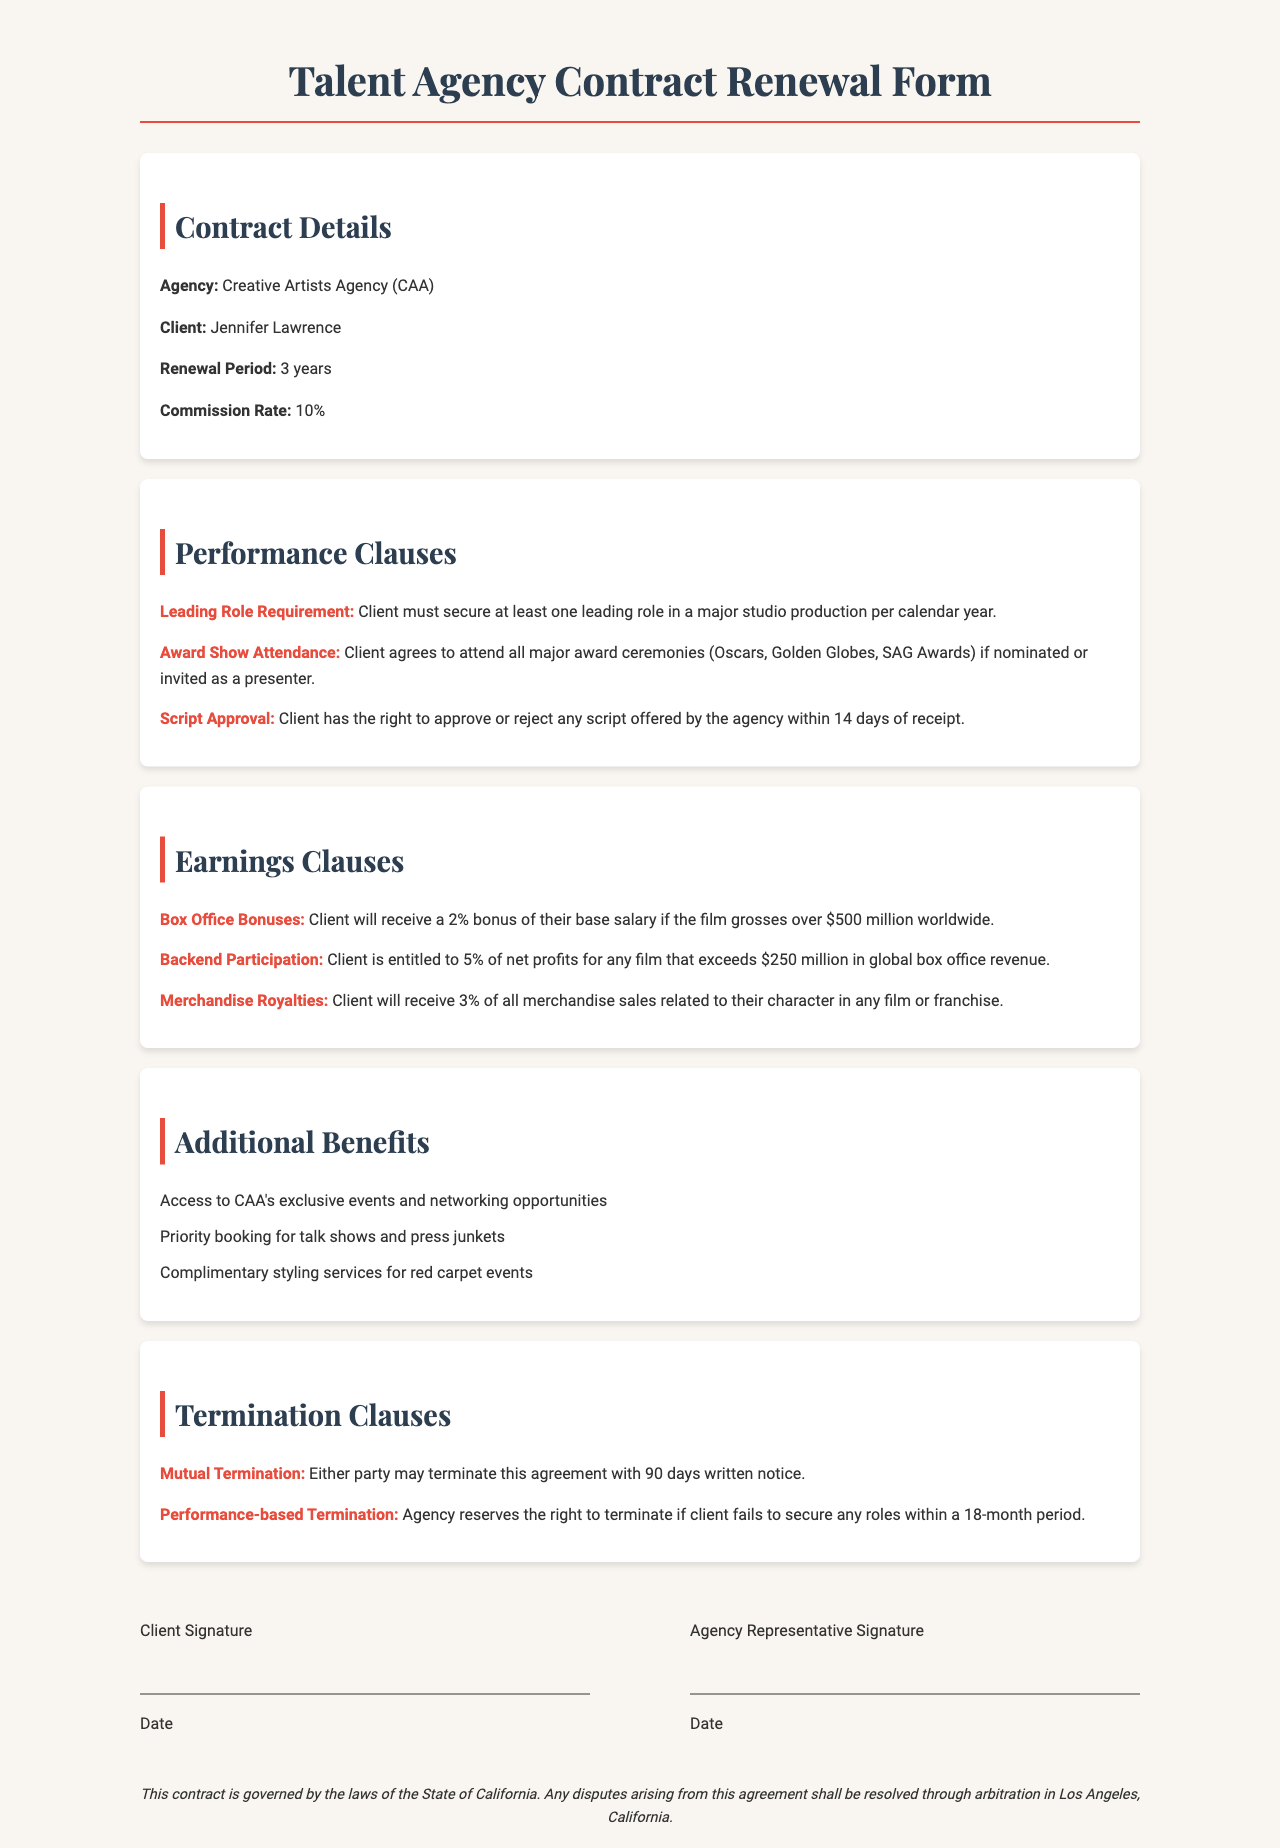What is the name of the agency? The document states that the agency is the Creative Artists Agency (CAA).
Answer: Creative Artists Agency (CAA) What is the contract renewal period? The contract renewal period specified in the document is three years.
Answer: 3 years What is the commission rate? The document lists the commission rate as 10 percent.
Answer: 10% What must the client secure in terms of leading roles? The performance clause requires the client to secure at least one leading role in a major studio production per calendar year.
Answer: One leading role What percentage of merchandise sales does the client receive? The earnings clause outlines that the client will receive 3 percent of all merchandise sales related to their character.
Answer: 3% What is the notice period for mutual termination? According to the termination clause, the notice period for mutual termination is 90 days.
Answer: 90 days What is the bonus percentage for box office earnings? The client will receive a 2 percent bonus of their base salary if the film grosses over $500 million worldwide, as stated in the earnings clause.
Answer: 2% What is required for the client regarding award ceremonies? The client agrees to attend all major award ceremonies if nominated or invited as a presenter, as per the performance clause.
Answer: Attend all major award ceremonies What is the governing law for this contract? The legal disclaimer indicates that the contract is governed by the laws of the State of California.
Answer: State of California 